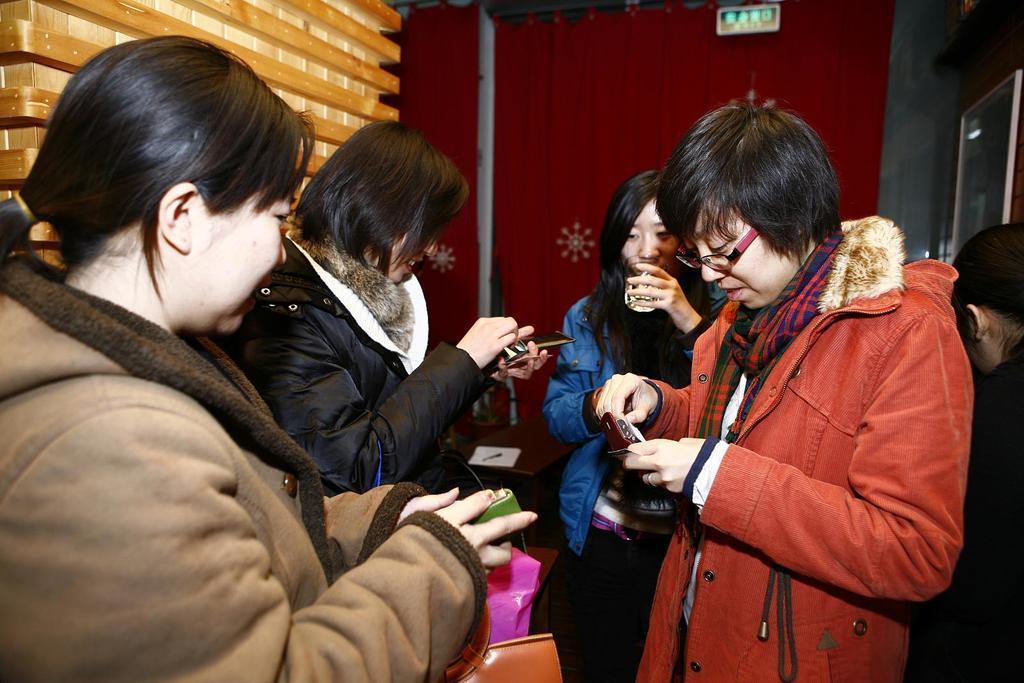In one or two sentences, can you explain what this image depicts? In this image we can see few people and they are holding objects. In the background we can see a board, wall, wooden object, glass, and a curtain. 